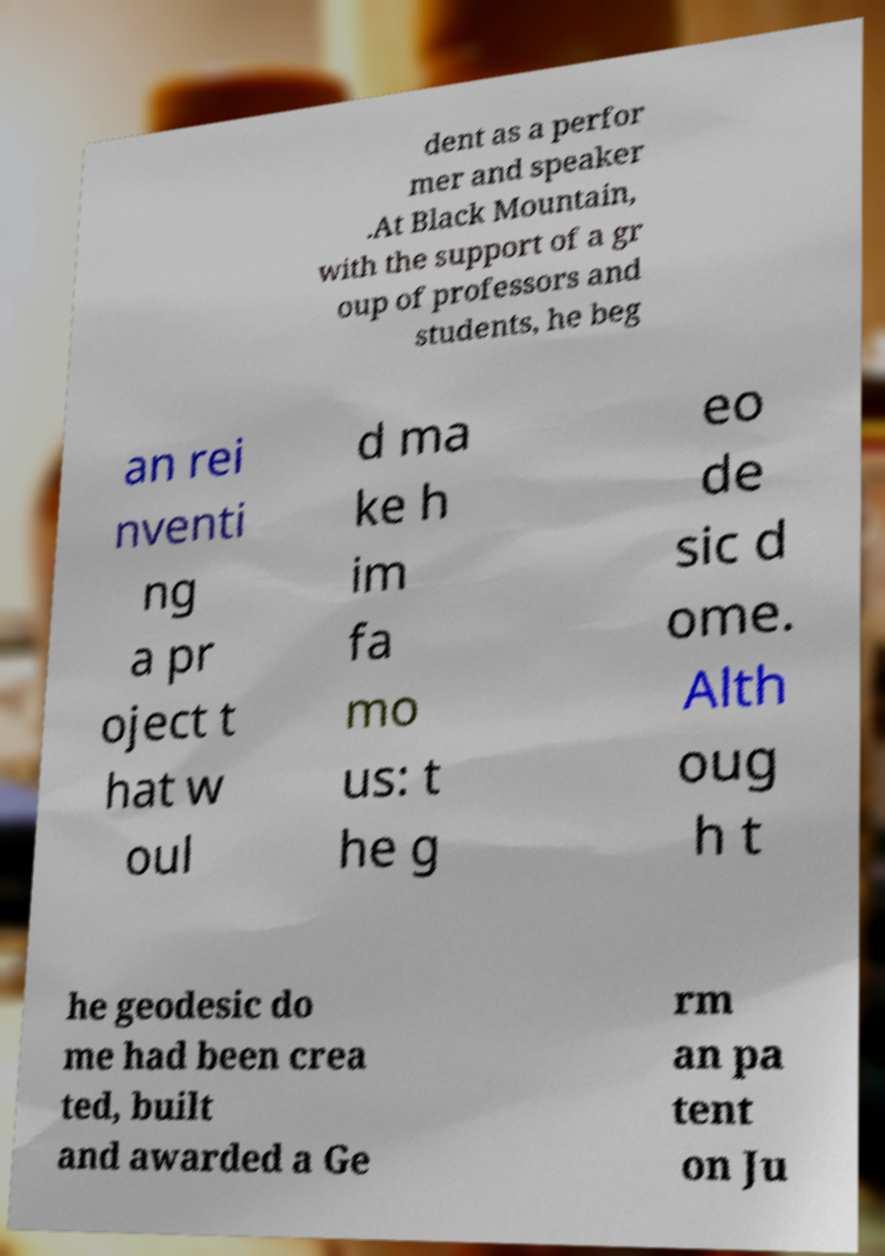There's text embedded in this image that I need extracted. Can you transcribe it verbatim? dent as a perfor mer and speaker .At Black Mountain, with the support of a gr oup of professors and students, he beg an rei nventi ng a pr oject t hat w oul d ma ke h im fa mo us: t he g eo de sic d ome. Alth oug h t he geodesic do me had been crea ted, built and awarded a Ge rm an pa tent on Ju 